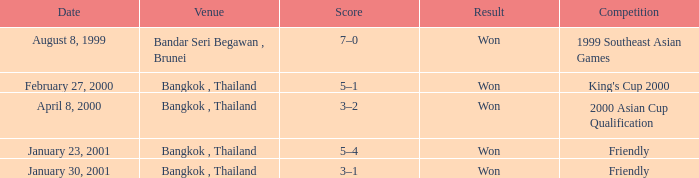During what competition was a game played with a score of 3–1? Friendly. 